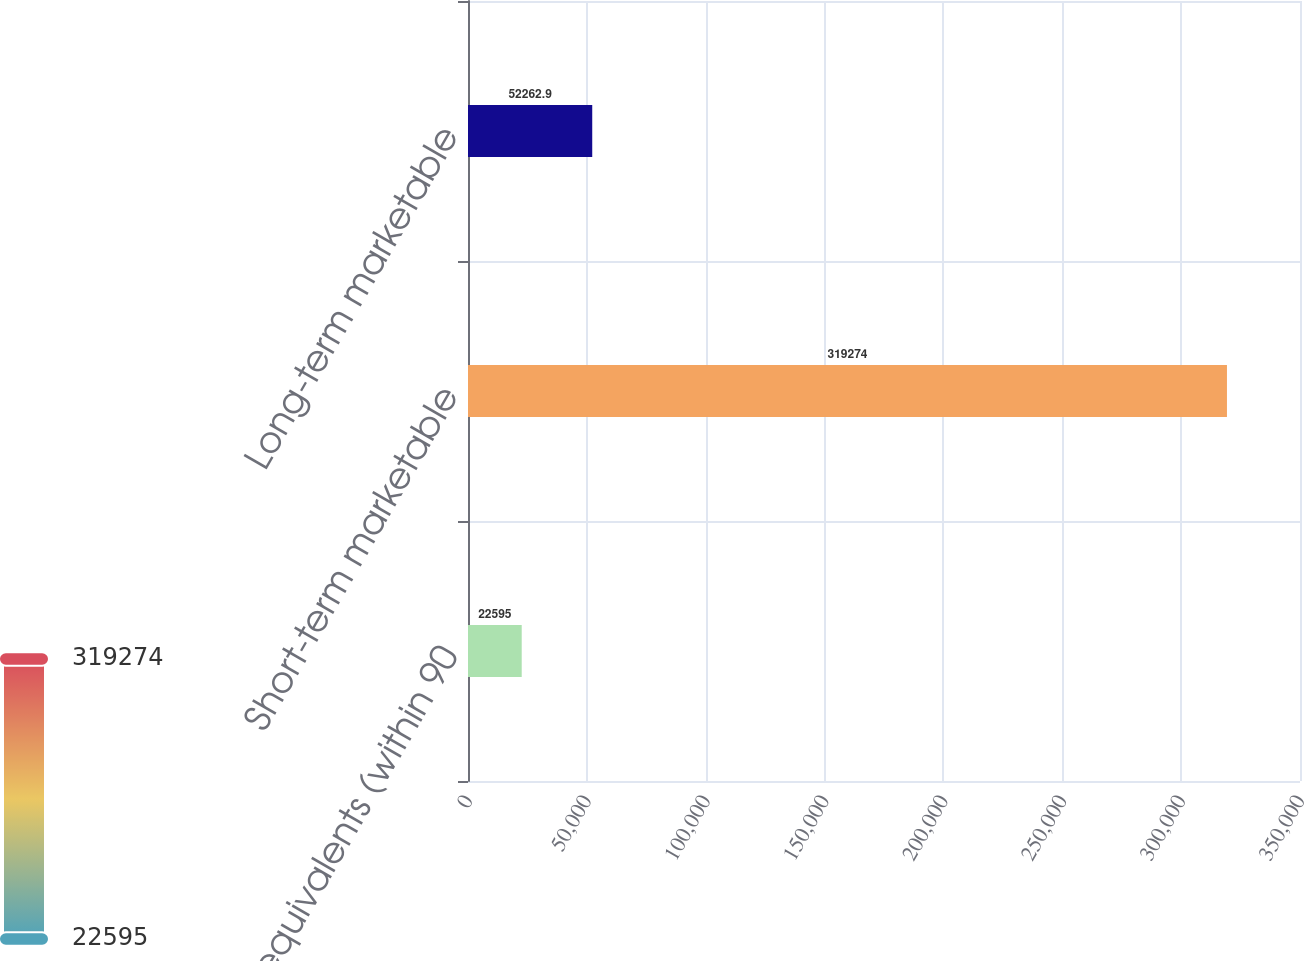Convert chart to OTSL. <chart><loc_0><loc_0><loc_500><loc_500><bar_chart><fcel>Cash equivalents (within 90<fcel>Short-term marketable<fcel>Long-term marketable<nl><fcel>22595<fcel>319274<fcel>52262.9<nl></chart> 